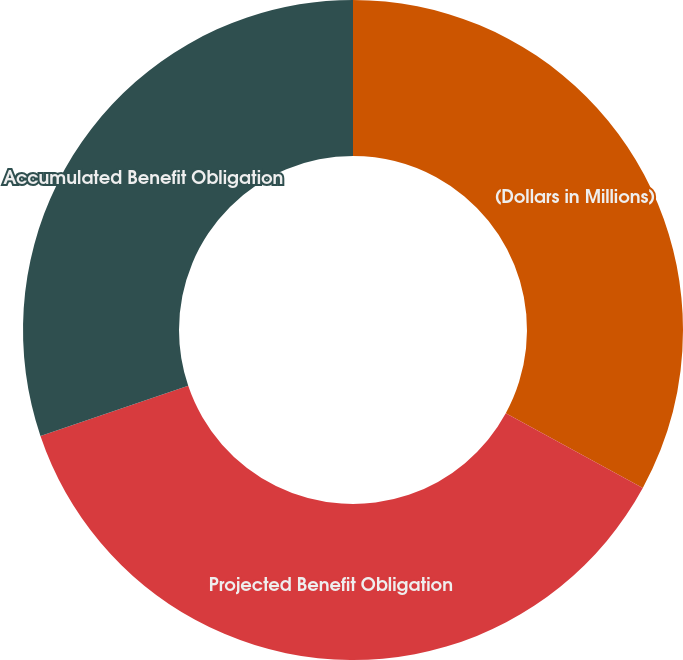Convert chart to OTSL. <chart><loc_0><loc_0><loc_500><loc_500><pie_chart><fcel>(Dollars in Millions)<fcel>Projected Benefit Obligation<fcel>Accumulated Benefit Obligation<nl><fcel>32.94%<fcel>36.86%<fcel>30.2%<nl></chart> 